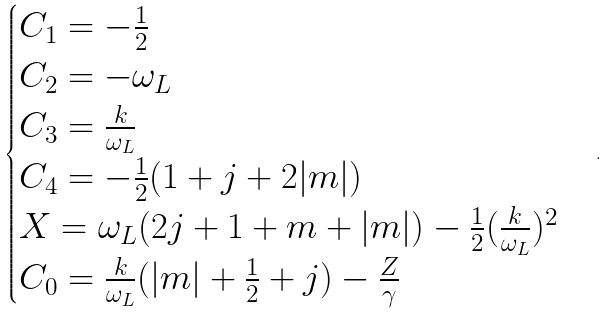<formula> <loc_0><loc_0><loc_500><loc_500>\begin{cases} C _ { 1 } = - \frac { 1 } { 2 } \\ C _ { 2 } = - \omega _ { L } \\ C _ { 3 } = \frac { k } { \omega _ { L } } \\ C _ { 4 } = - \frac { 1 } { 2 } ( 1 + j + 2 | m | ) \\ X = \omega _ { L } ( 2 j + 1 + m + | m | ) - \frac { 1 } { 2 } ( \frac { k } { \omega _ { L } } ) ^ { 2 } \\ C _ { 0 } = \frac { k } { \omega _ { L } } ( | m | + \frac { 1 } { 2 } + j ) - \frac { Z } { \gamma } \end{cases} .</formula> 